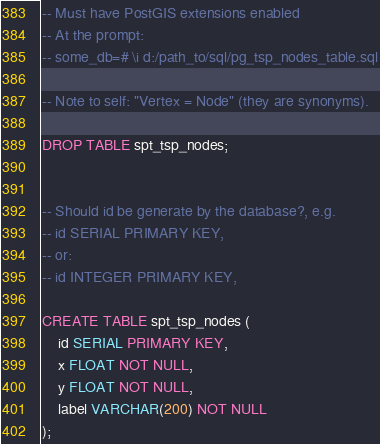Convert code to text. <code><loc_0><loc_0><loc_500><loc_500><_SQL_>-- Must have PostGIS extensions enabled
-- At the prompt:
-- some_db=# \i d:/path_to/sql/pg_tsp_nodes_table.sql

-- Note to self: "Vertex = Node" (they are synonyms).

DROP TABLE spt_tsp_nodes;


-- Should id be generate by the database?, e.g.
-- id SERIAL PRIMARY KEY,
-- or:
-- id INTEGER PRIMARY KEY,

CREATE TABLE spt_tsp_nodes (
    id SERIAL PRIMARY KEY,
    x FLOAT NOT NULL, 
    y FLOAT NOT NULL,
    label VARCHAR(200) NOT NULL
);



</code> 